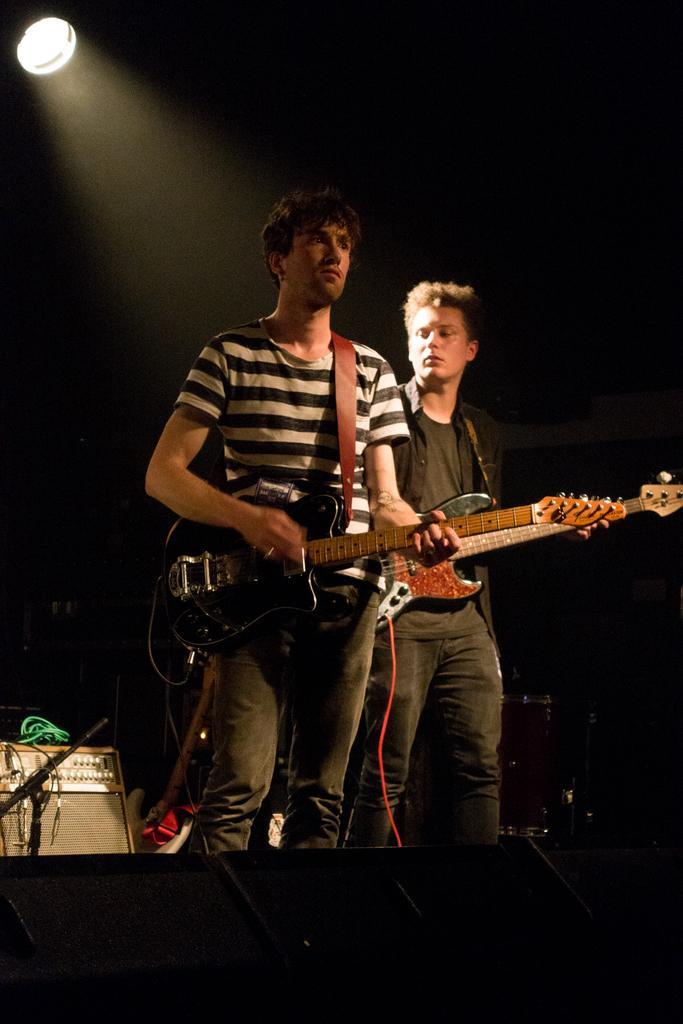Could you give a brief overview of what you see in this image? Here we can see two men standing on a stage playing guitars and there are other musical instruments present behind them and we can see a light at the top 